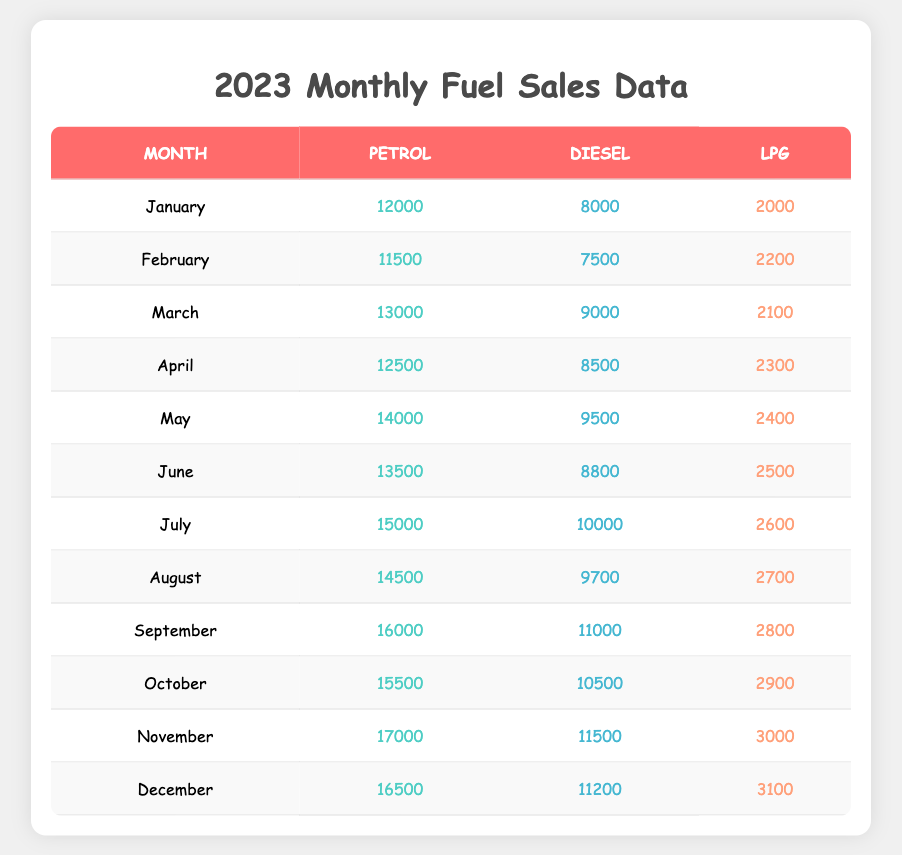What is the total amount of petrol sold in January 2023? In January 2023, the petrol sold is listed as 12000. Therefore, the total amount of petrol sold in that month is simply this value.
Answer: 12000 What was the highest value of diesel sold in any month? By checking the diesel sales data for each month, we find that the highest value is in November, where 11500 units were sold.
Answer: 11500 Which month had the lowest amount of LPG sold? Looking at the LPG data, January shows the lowest sales at 2000 units.
Answer: January What is the total sales of diesel from May to August? We calculate the total diesel sales from May (9500) + June (8800) + July (10000) + August (9700). Summing these gives us 9500 + 8800 + 10000 + 9700 = 39600.
Answer: 39600 In which month did petrol sales exceed 15000? Going through the petrol data, we find that July, August, September, October, November, and December all exceed 15000. Since the question asks for the first instance, the answer is July, which had the first occurrences above this threshold.
Answer: July Were there any months when LPG sales were higher than 2500? Checking the LPG sales data, July (2600) and subsequent months (August, September, October, November, December) all have higher sales than 2500, confirming that there are indeed months with higher sales.
Answer: Yes Calculate the average amount of petrol sold over the year. To find the average petrol sales, we sum all the monthly sales: 12000 + 11500 + 13000 + 12500 + 14000 + 13500 + 15000 + 14500 + 16000 + 15500 + 17000 + 16500 = 162000. There are 12 months, so the average is 162000 / 12 = 13500.
Answer: 13500 Which month had the highest total fuel sales (petrol, diesel, and LPG combined)? To find the month with the highest total sales, we calculate the total for each month by summing petrol, diesel, and LPG:  
- January: 12000 + 8000 + 2000 = 22000  
- February: 11500 + 7500 + 2200 = 21200  
- March: 13000 + 9000 + 2100 = 24100  
- April: 12500 + 8500 + 2300 = 23300  
- May: 14000 + 9500 + 2400 = 25900  
- June: 13500 + 8800 + 2500 = 24800  
- July: 15000 + 10000 + 2600 = 27600  
- August: 14500 + 9700 + 2700 = 26900  
- September: 16000 + 11000 + 2800 = 29800  
- October: 15500 + 10500 + 2900 = 28300  
- November: 17000 + 11500 + 3000 = 31500  
- December: 16500 + 11200 + 3100 = 30700  
The highest total sales was in November with 31500.
Answer: November 